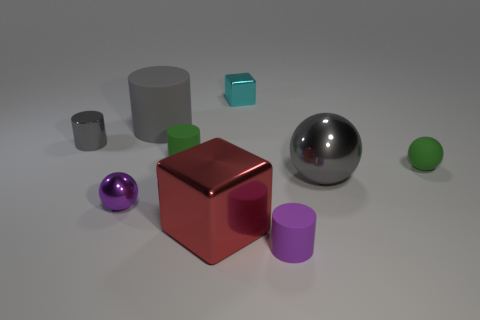There is a small object to the right of the gray metal thing that is in front of the tiny green matte cylinder; what is its material?
Offer a very short reply. Rubber. What is the tiny purple thing right of the purple metallic ball made of?
Keep it short and to the point. Rubber. What number of small green objects are the same shape as the large red object?
Your answer should be compact. 0. Does the shiny cylinder have the same color as the big rubber object?
Offer a very short reply. Yes. There is a tiny cylinder that is in front of the green matte thing that is right of the tiny cyan block that is behind the small green ball; what is it made of?
Ensure brevity in your answer.  Rubber. There is a tiny shiny cube; are there any tiny gray metal cylinders right of it?
Give a very brief answer. No. There is a red object that is the same size as the gray sphere; what shape is it?
Your response must be concise. Cube. Is the material of the large ball the same as the cyan block?
Give a very brief answer. Yes. How many rubber objects are either balls or tiny purple balls?
Your response must be concise. 1. The metallic thing that is the same color as the tiny metal cylinder is what shape?
Give a very brief answer. Sphere. 